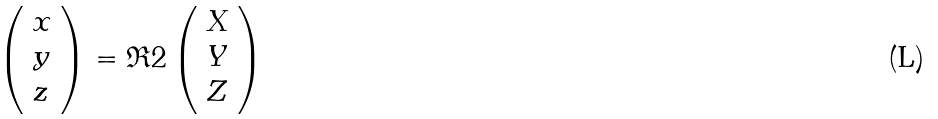<formula> <loc_0><loc_0><loc_500><loc_500>\left ( \begin{array} { l } x \\ y \\ z \end{array} \right ) = \mathfrak { R } 2 \left ( \begin{array} { l } X \\ Y \\ Z \end{array} \right )</formula> 